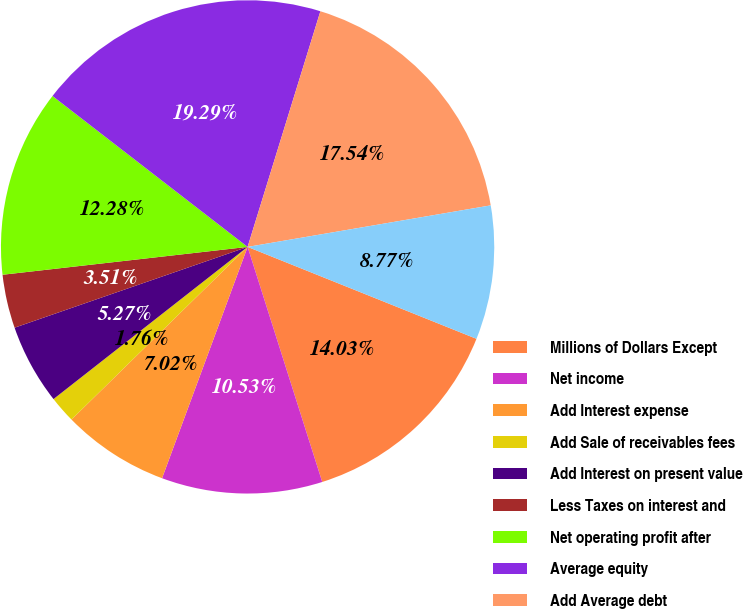Convert chart. <chart><loc_0><loc_0><loc_500><loc_500><pie_chart><fcel>Millions of Dollars Except<fcel>Net income<fcel>Add Interest expense<fcel>Add Sale of receivables fees<fcel>Add Interest on present value<fcel>Less Taxes on interest and<fcel>Net operating profit after<fcel>Average equity<fcel>Add Average debt<fcel>Add Average value of sold<nl><fcel>14.03%<fcel>10.53%<fcel>7.02%<fcel>1.76%<fcel>5.27%<fcel>3.51%<fcel>12.28%<fcel>19.29%<fcel>17.54%<fcel>8.77%<nl></chart> 